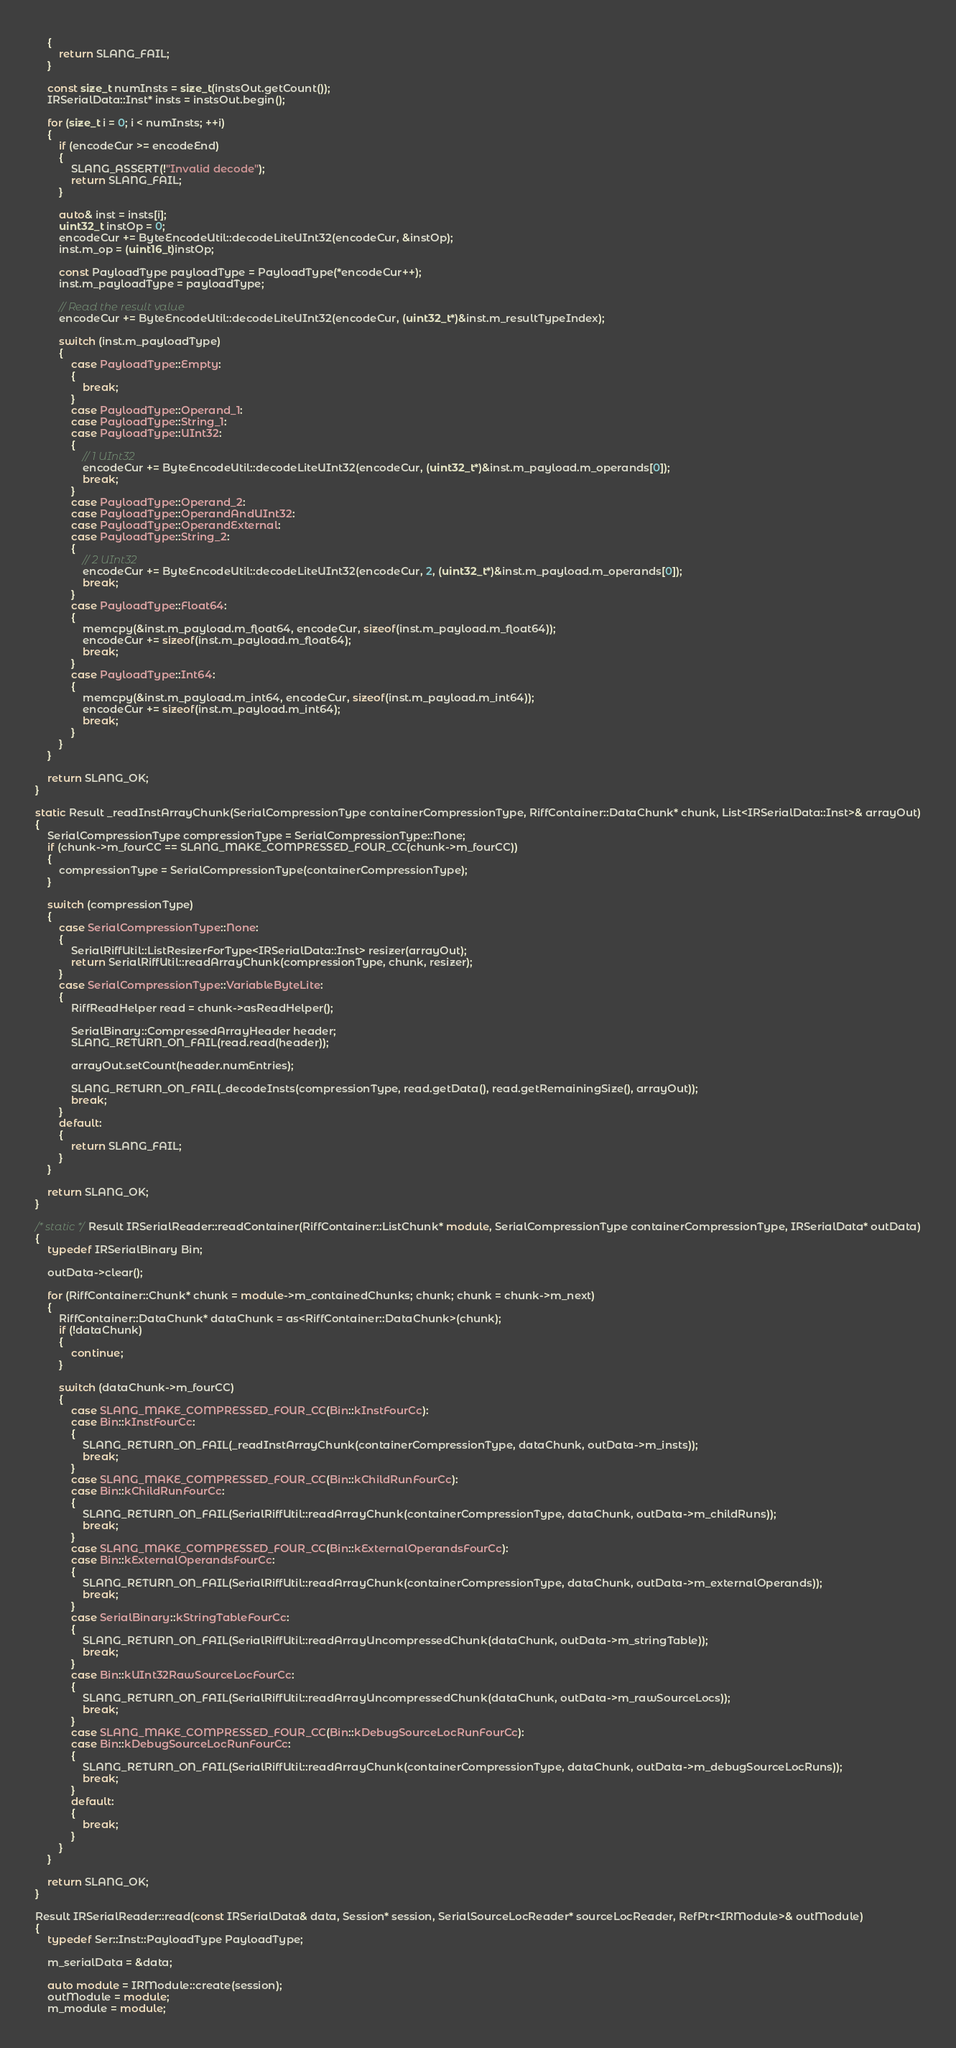<code> <loc_0><loc_0><loc_500><loc_500><_C++_>    {
        return SLANG_FAIL;
    }

    const size_t numInsts = size_t(instsOut.getCount());
    IRSerialData::Inst* insts = instsOut.begin();

    for (size_t i = 0; i < numInsts; ++i)
    {
        if (encodeCur >= encodeEnd)
        {
            SLANG_ASSERT(!"Invalid decode");
            return SLANG_FAIL;
        }

        auto& inst = insts[i];
        uint32_t instOp = 0;
        encodeCur += ByteEncodeUtil::decodeLiteUInt32(encodeCur, &instOp);
        inst.m_op = (uint16_t)instOp;

        const PayloadType payloadType = PayloadType(*encodeCur++);
        inst.m_payloadType = payloadType;
        
        // Read the result value
        encodeCur += ByteEncodeUtil::decodeLiteUInt32(encodeCur, (uint32_t*)&inst.m_resultTypeIndex);

        switch (inst.m_payloadType)
        {
            case PayloadType::Empty:
            {
                break;
            }
            case PayloadType::Operand_1:
            case PayloadType::String_1:
            case PayloadType::UInt32:
            {
                // 1 UInt32
                encodeCur += ByteEncodeUtil::decodeLiteUInt32(encodeCur, (uint32_t*)&inst.m_payload.m_operands[0]);
                break;
            }
            case PayloadType::Operand_2:
            case PayloadType::OperandAndUInt32:
            case PayloadType::OperandExternal:
            case PayloadType::String_2:
            {
                // 2 UInt32
                encodeCur += ByteEncodeUtil::decodeLiteUInt32(encodeCur, 2, (uint32_t*)&inst.m_payload.m_operands[0]);
                break;
            }
            case PayloadType::Float64:
            {
                memcpy(&inst.m_payload.m_float64, encodeCur, sizeof(inst.m_payload.m_float64));
                encodeCur += sizeof(inst.m_payload.m_float64);
                break;
            }
            case PayloadType::Int64:
            {
                memcpy(&inst.m_payload.m_int64, encodeCur, sizeof(inst.m_payload.m_int64));
                encodeCur += sizeof(inst.m_payload.m_int64);
                break;
            }
        }
    }

    return SLANG_OK;
}

static Result _readInstArrayChunk(SerialCompressionType containerCompressionType, RiffContainer::DataChunk* chunk, List<IRSerialData::Inst>& arrayOut)
{
    SerialCompressionType compressionType = SerialCompressionType::None;
    if (chunk->m_fourCC == SLANG_MAKE_COMPRESSED_FOUR_CC(chunk->m_fourCC))
    {
        compressionType = SerialCompressionType(containerCompressionType);
    }

    switch (compressionType)
    {
        case SerialCompressionType::None:
        {
            SerialRiffUtil::ListResizerForType<IRSerialData::Inst> resizer(arrayOut);
            return SerialRiffUtil::readArrayChunk(compressionType, chunk, resizer);
        }
        case SerialCompressionType::VariableByteLite:
        {
            RiffReadHelper read = chunk->asReadHelper();

            SerialBinary::CompressedArrayHeader header;
            SLANG_RETURN_ON_FAIL(read.read(header));

            arrayOut.setCount(header.numEntries);

            SLANG_RETURN_ON_FAIL(_decodeInsts(compressionType, read.getData(), read.getRemainingSize(), arrayOut));
            break;
        }
        default:
        {
            return SLANG_FAIL;
        }
    }

    return SLANG_OK;
}

/* static */Result IRSerialReader::readContainer(RiffContainer::ListChunk* module, SerialCompressionType containerCompressionType, IRSerialData* outData)
{
    typedef IRSerialBinary Bin;

    outData->clear();

    for (RiffContainer::Chunk* chunk = module->m_containedChunks; chunk; chunk = chunk->m_next)
    {
        RiffContainer::DataChunk* dataChunk = as<RiffContainer::DataChunk>(chunk);
        if (!dataChunk)
        {
            continue;
        }
        
        switch (dataChunk->m_fourCC)
        {
            case SLANG_MAKE_COMPRESSED_FOUR_CC(Bin::kInstFourCc):
            case Bin::kInstFourCc:
            {
                SLANG_RETURN_ON_FAIL(_readInstArrayChunk(containerCompressionType, dataChunk, outData->m_insts));
                break;
            }
            case SLANG_MAKE_COMPRESSED_FOUR_CC(Bin::kChildRunFourCc):
            case Bin::kChildRunFourCc:
            {
                SLANG_RETURN_ON_FAIL(SerialRiffUtil::readArrayChunk(containerCompressionType, dataChunk, outData->m_childRuns));
                break;
            }
            case SLANG_MAKE_COMPRESSED_FOUR_CC(Bin::kExternalOperandsFourCc):
            case Bin::kExternalOperandsFourCc:
            {
                SLANG_RETURN_ON_FAIL(SerialRiffUtil::readArrayChunk(containerCompressionType, dataChunk, outData->m_externalOperands));
                break;
            }
            case SerialBinary::kStringTableFourCc:
            {
                SLANG_RETURN_ON_FAIL(SerialRiffUtil::readArrayUncompressedChunk(dataChunk, outData->m_stringTable));
                break;
            }
            case Bin::kUInt32RawSourceLocFourCc:
            {
                SLANG_RETURN_ON_FAIL(SerialRiffUtil::readArrayUncompressedChunk(dataChunk, outData->m_rawSourceLocs));
                break;
            }
            case SLANG_MAKE_COMPRESSED_FOUR_CC(Bin::kDebugSourceLocRunFourCc):
            case Bin::kDebugSourceLocRunFourCc:
            {
                SLANG_RETURN_ON_FAIL(SerialRiffUtil::readArrayChunk(containerCompressionType, dataChunk, outData->m_debugSourceLocRuns));
                break;
            }
            default:
            {
                break;
            }
        }
    }

    return SLANG_OK;
}

Result IRSerialReader::read(const IRSerialData& data, Session* session, SerialSourceLocReader* sourceLocReader, RefPtr<IRModule>& outModule)
{
    typedef Ser::Inst::PayloadType PayloadType;

    m_serialData = &data;

    auto module = IRModule::create(session);
    outModule = module;
    m_module = module;
</code> 